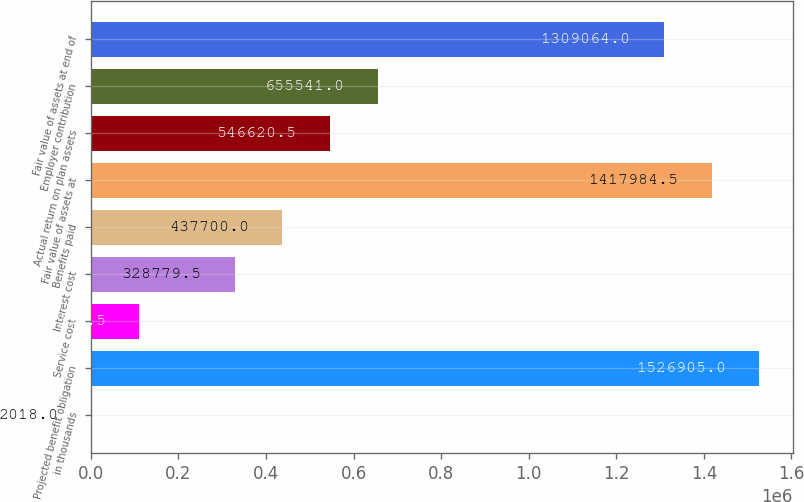Convert chart to OTSL. <chart><loc_0><loc_0><loc_500><loc_500><bar_chart><fcel>in thousands<fcel>Projected benefit obligation<fcel>Service cost<fcel>Interest cost<fcel>Benefits paid<fcel>Fair value of assets at<fcel>Actual return on plan assets<fcel>Employer contribution<fcel>Fair value of assets at end of<nl><fcel>2018<fcel>1.5269e+06<fcel>110938<fcel>328780<fcel>437700<fcel>1.41798e+06<fcel>546620<fcel>655541<fcel>1.30906e+06<nl></chart> 